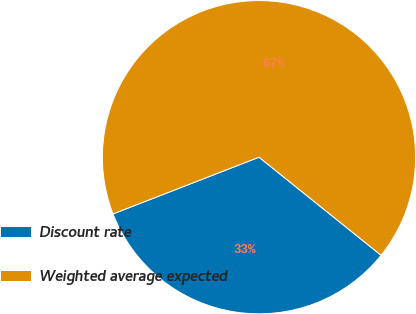Convert chart. <chart><loc_0><loc_0><loc_500><loc_500><pie_chart><fcel>Discount rate<fcel>Weighted average expected<nl><fcel>33.33%<fcel>66.67%<nl></chart> 